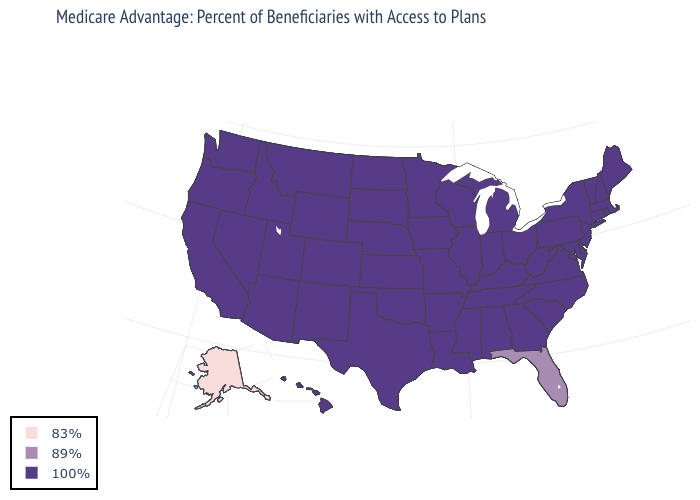What is the highest value in the USA?
Write a very short answer. 100%. What is the value of Colorado?
Write a very short answer. 100%. What is the highest value in the West ?
Short answer required. 100%. Which states have the highest value in the USA?
Quick response, please. Alabama, Arkansas, Arizona, California, Colorado, Connecticut, Delaware, Georgia, Hawaii, Iowa, Idaho, Illinois, Indiana, Kansas, Kentucky, Louisiana, Massachusetts, Maryland, Maine, Michigan, Minnesota, Missouri, Mississippi, Montana, North Carolina, North Dakota, Nebraska, New Hampshire, New Jersey, New Mexico, Nevada, New York, Ohio, Oklahoma, Oregon, Pennsylvania, Rhode Island, South Carolina, South Dakota, Tennessee, Texas, Utah, Virginia, Vermont, Washington, Wisconsin, West Virginia, Wyoming. Does Wyoming have the same value as California?
Short answer required. Yes. Name the states that have a value in the range 83%?
Answer briefly. Alaska. Among the states that border South Carolina , which have the highest value?
Answer briefly. Georgia, North Carolina. Among the states that border New Hampshire , which have the lowest value?
Give a very brief answer. Massachusetts, Maine, Vermont. Does Florida have the lowest value in the South?
Quick response, please. Yes. Name the states that have a value in the range 89%?
Concise answer only. Florida. What is the value of Massachusetts?
Write a very short answer. 100%. What is the value of Maryland?
Give a very brief answer. 100%. What is the value of Louisiana?
Be succinct. 100%. What is the value of Minnesota?
Keep it brief. 100%. 